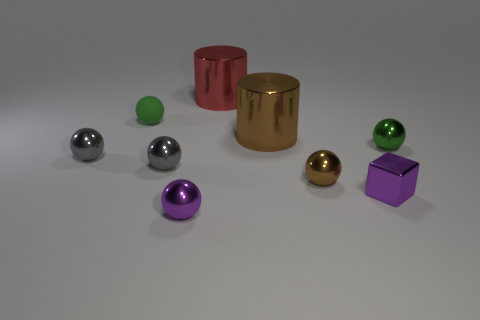What color is the big object that is in front of the cylinder behind the tiny green matte sphere?
Your answer should be compact. Brown. Is the green shiny thing the same size as the purple sphere?
Keep it short and to the point. Yes. Are the green thing on the left side of the red metallic object and the cylinder that is on the right side of the red thing made of the same material?
Your answer should be very brief. No. The purple metal thing that is to the right of the small purple thing that is on the left side of the big thing in front of the red metallic cylinder is what shape?
Provide a succinct answer. Cube. Is the number of small cyan shiny things greater than the number of tiny gray things?
Your response must be concise. No. Is there a gray rubber cylinder?
Offer a terse response. No. What number of things are tiny metallic balls that are behind the purple shiny cube or green balls on the left side of the red metallic thing?
Offer a very short reply. 5. Do the small matte object and the small metal cube have the same color?
Provide a short and direct response. No. Is the number of shiny spheres less than the number of small green rubber things?
Ensure brevity in your answer.  No. Are there any small cubes to the left of the small green rubber thing?
Provide a succinct answer. No. 